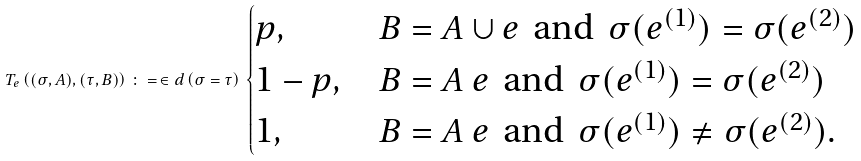Convert formula to latex. <formula><loc_0><loc_0><loc_500><loc_500>T _ { e } \left ( ( \sigma , A ) , ( \tau , B ) \right ) \, \colon = \, \in d \left ( \sigma = \tau \right ) \, \begin{cases} p , & B = A \cup e \, \text { and } \, \sigma ( e ^ { ( 1 ) } ) = \sigma ( e ^ { ( 2 ) } ) \\ 1 - p , & B = A \ e \, \text { and } \, \sigma ( e ^ { ( 1 ) } ) = \sigma ( e ^ { ( 2 ) } ) \\ 1 , & B = A \ e \, \text { and } \, \sigma ( e ^ { ( 1 ) } ) \ne \sigma ( e ^ { ( 2 ) } ) . \end{cases}</formula> 